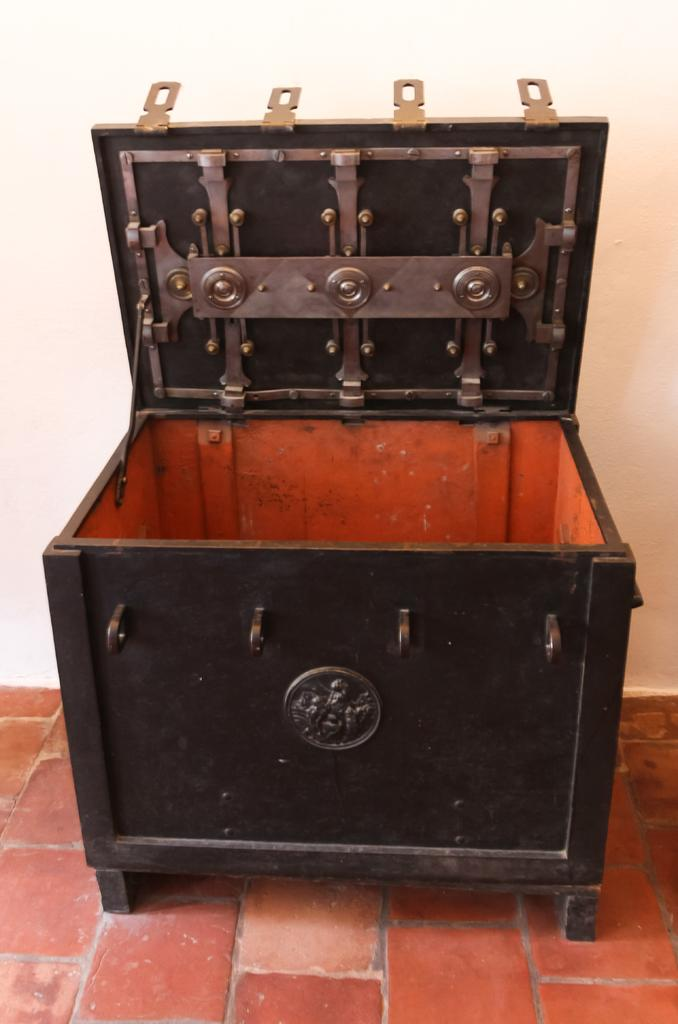What is the main object in the center of the image? There is a wooden box in the center of the image. What can be seen at the bottom of the image? The floor is visible at the bottom of the image. What is located behind the wooden box in the image? There is a wall in the background of the image. What color is the wall in the image? The wall is painted white. How many books does the uncle have control over in the image? There are no books or uncles present in the image, so it is not possible to determine how many books the uncle has control over. 